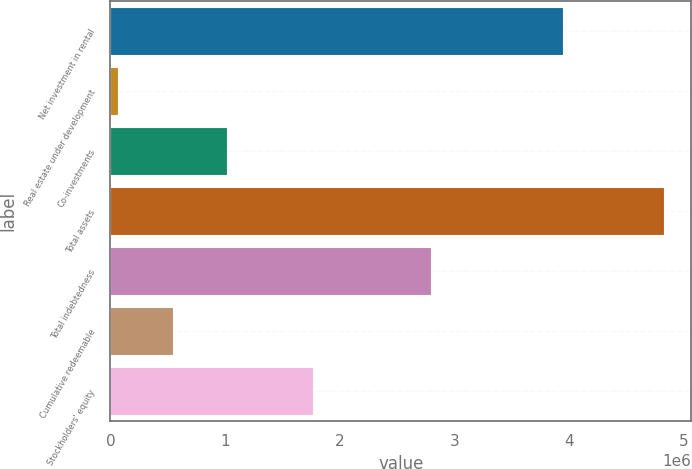Convert chart to OTSL. <chart><loc_0><loc_0><loc_500><loc_500><bar_chart><fcel>Net investment in rental<fcel>Real estate under development<fcel>Co-investments<fcel>Total assets<fcel>Total indebtedness<fcel>Cumulative redeemable<fcel>Stockholders' equity<nl><fcel>3.95216e+06<fcel>66851<fcel>1.01875e+06<fcel>4.82636e+06<fcel>2.79782e+06<fcel>542802<fcel>1.7648e+06<nl></chart> 